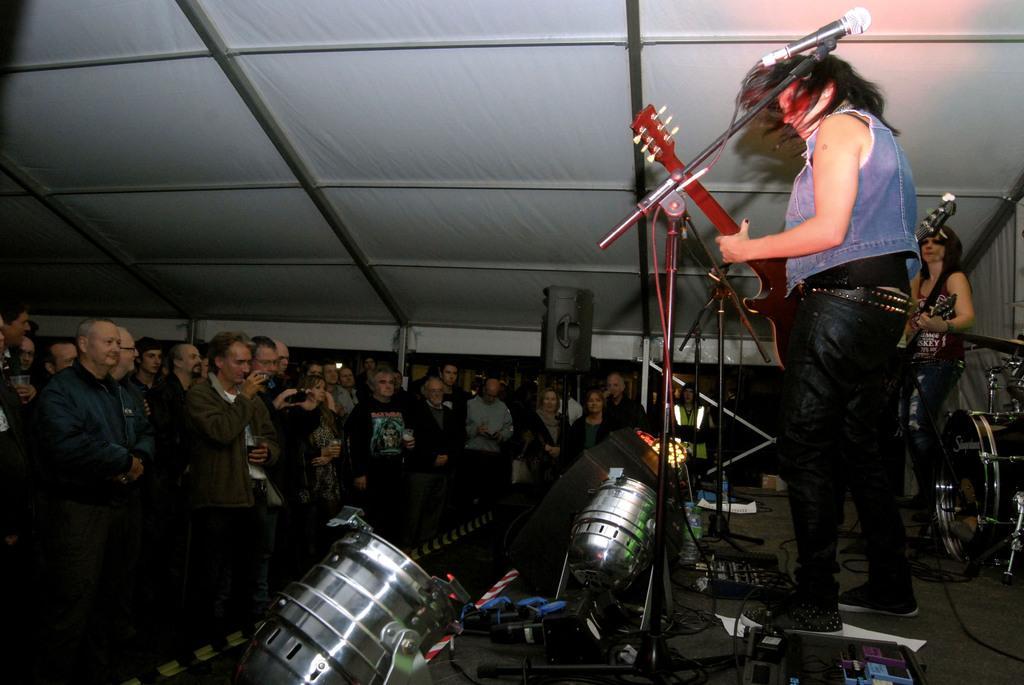Describe this image in one or two sentences. In this image, we can see two people standing on the stage, they are holding guitars, we can see the microphones, there are some people standing, at the top we can see the shed. 